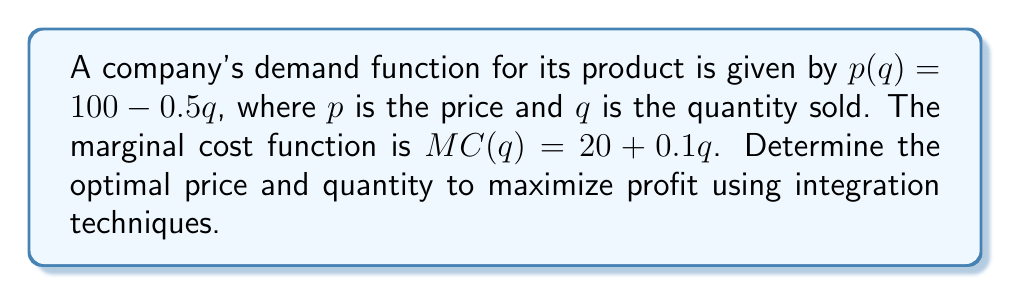Could you help me with this problem? 1. The profit function Π(q) is the difference between total revenue and total cost:
   Π(q) = TR(q) - TC(q)

2. Total revenue is the integral of the demand function:
   $TR(q) = \int_0^q p(q) dq = \int_0^q (100 - 0.5q) dq = 100q - 0.25q^2$

3. Total cost is the integral of the marginal cost function:
   $TC(q) = \int_0^q MC(q) dq = \int_0^q (20 + 0.1q) dq = 20q + 0.05q^2$

4. The profit function is:
   $Π(q) = TR(q) - TC(q) = (100q - 0.25q^2) - (20q + 0.05q^2) = 80q - 0.3q^2$

5. To maximize profit, find where the derivative of Π(q) equals zero:
   $\frac{d}{dq}Π(q) = 80 - 0.6q = 0$
   $0.6q = 80$
   $q = \frac{80}{0.6} = 133.33$

6. The optimal quantity is 133.33 units.

7. To find the optimal price, substitute this quantity into the demand function:
   $p(133.33) = 100 - 0.5(133.33) = 33.33$

Therefore, the optimal price is $33.33.
Answer: Optimal price: $33.33; Optimal quantity: 133.33 units 